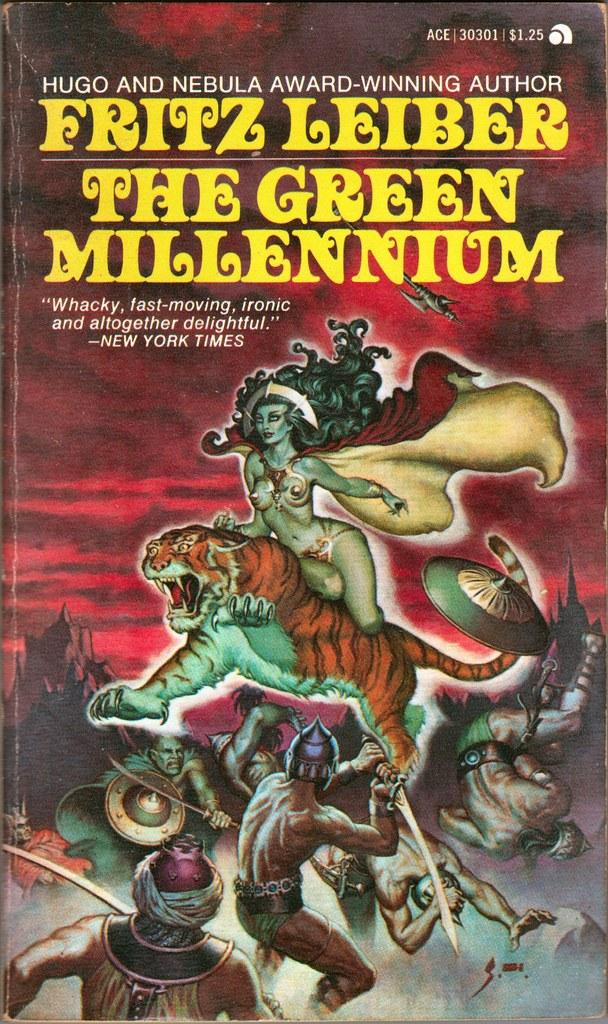<image>
Provide a brief description of the given image. A paperback book by Fritz Leiber called The Green Millennium. 